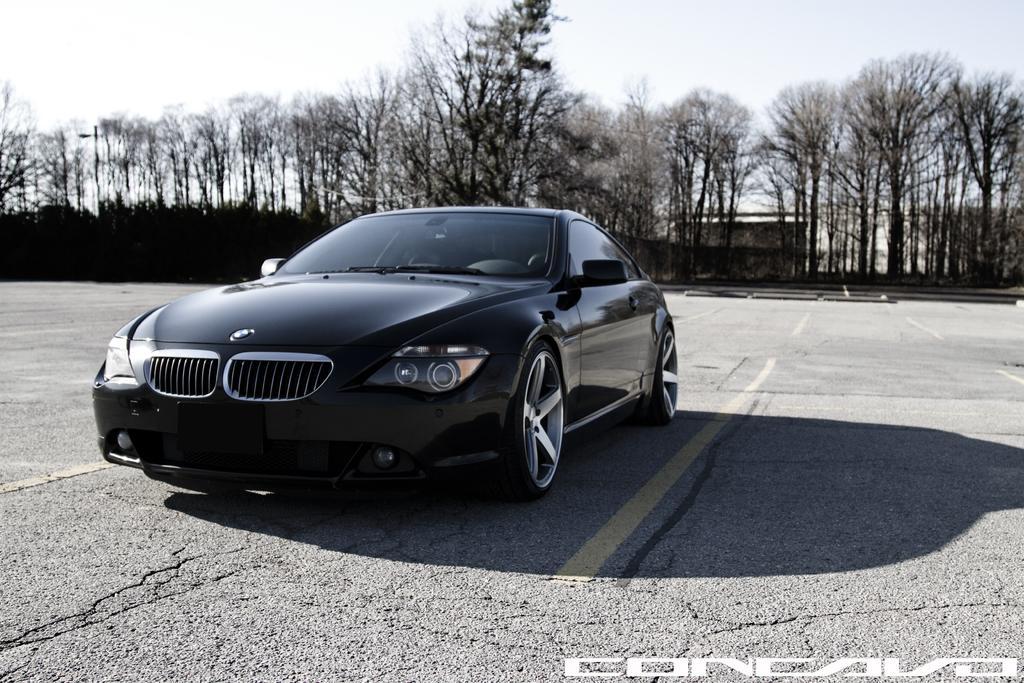Please provide a concise description of this image. We can see car on the road. In the background we can see trees and sky. In the bottom right side of the image we can see text. 